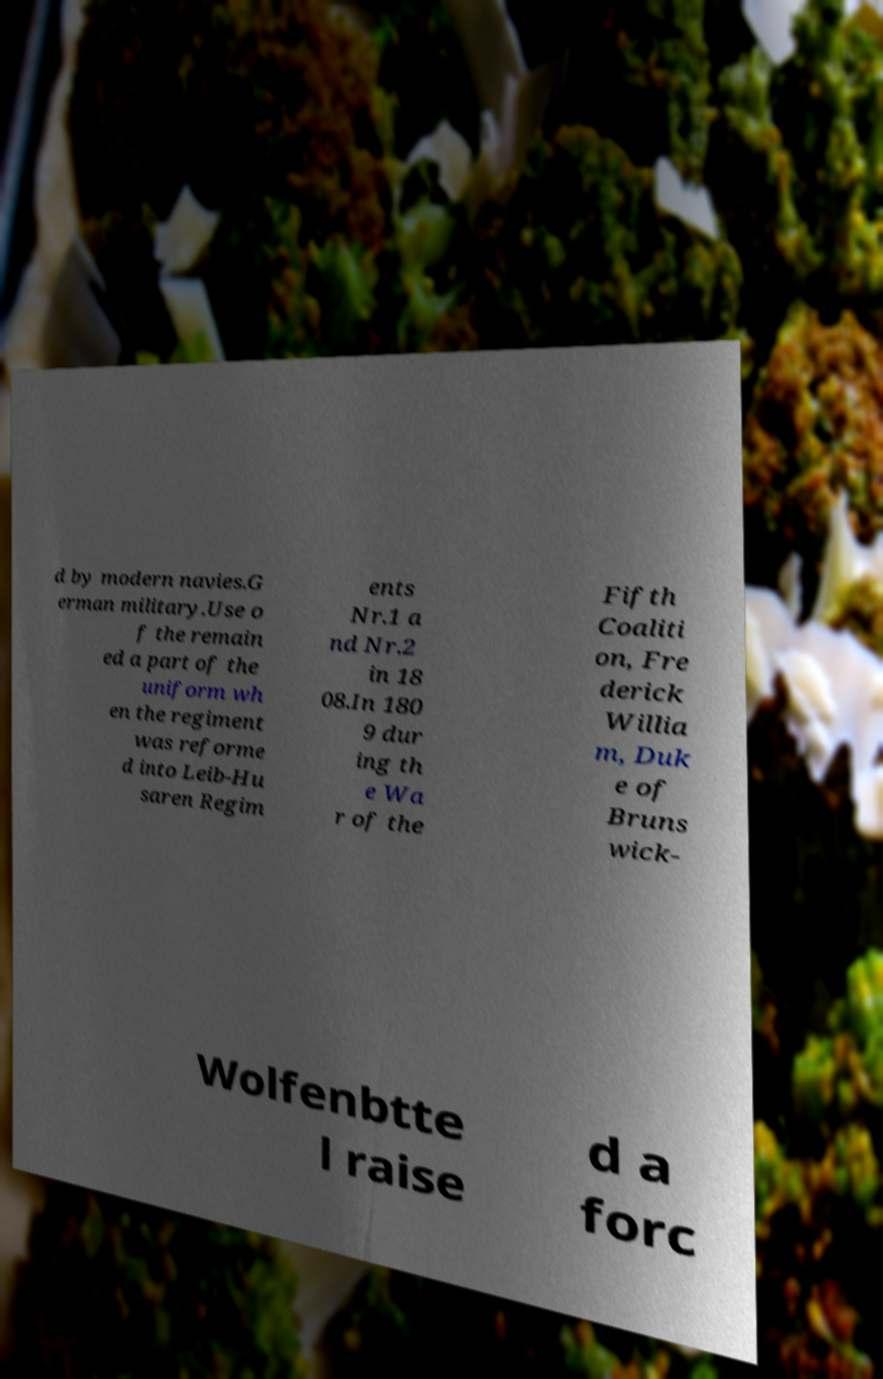Please identify and transcribe the text found in this image. d by modern navies.G erman military.Use o f the remain ed a part of the uniform wh en the regiment was reforme d into Leib-Hu saren Regim ents Nr.1 a nd Nr.2 in 18 08.In 180 9 dur ing th e Wa r of the Fifth Coaliti on, Fre derick Willia m, Duk e of Bruns wick- Wolfenbtte l raise d a forc 